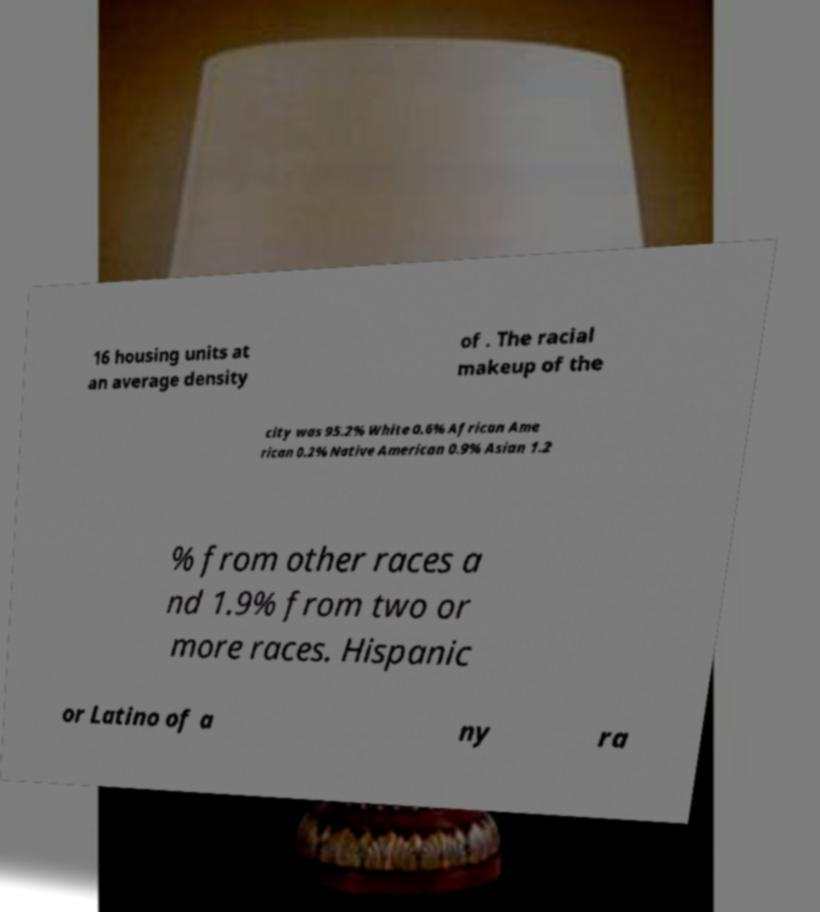Could you assist in decoding the text presented in this image and type it out clearly? 16 housing units at an average density of . The racial makeup of the city was 95.2% White 0.6% African Ame rican 0.2% Native American 0.9% Asian 1.2 % from other races a nd 1.9% from two or more races. Hispanic or Latino of a ny ra 